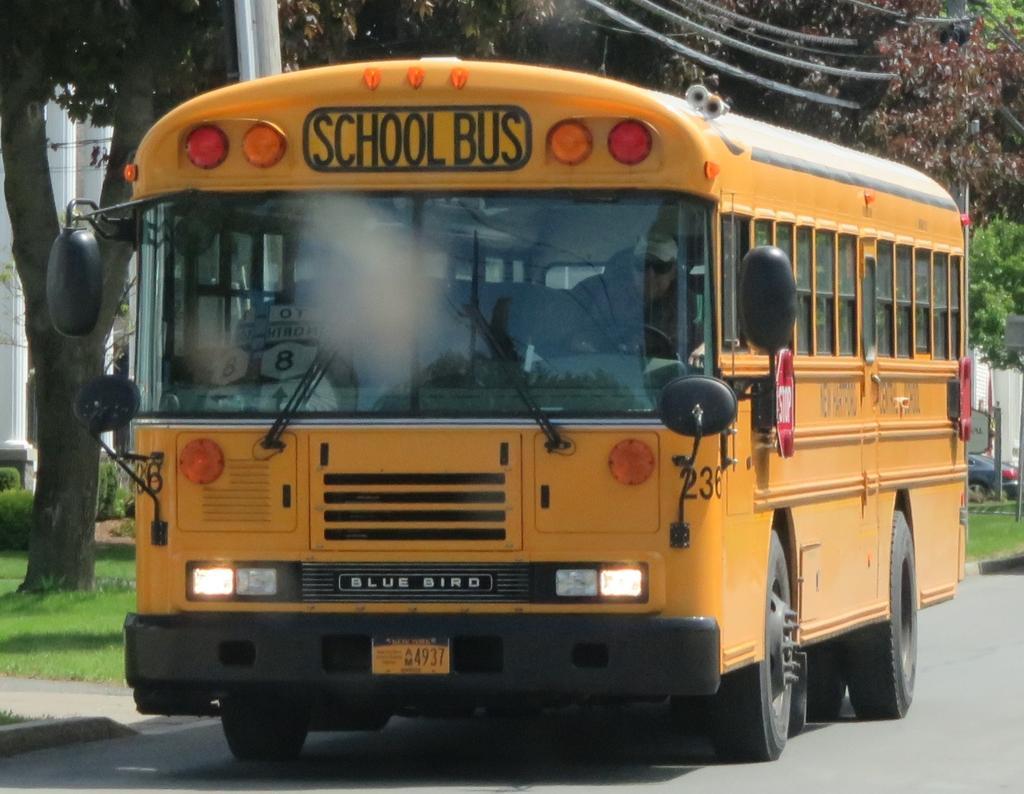How would you summarize this image in a sentence or two? In this image we can see a school bus on the road. In the background we can see the trees and also electrical poles with wires. Building and grass are also visible in this image. 